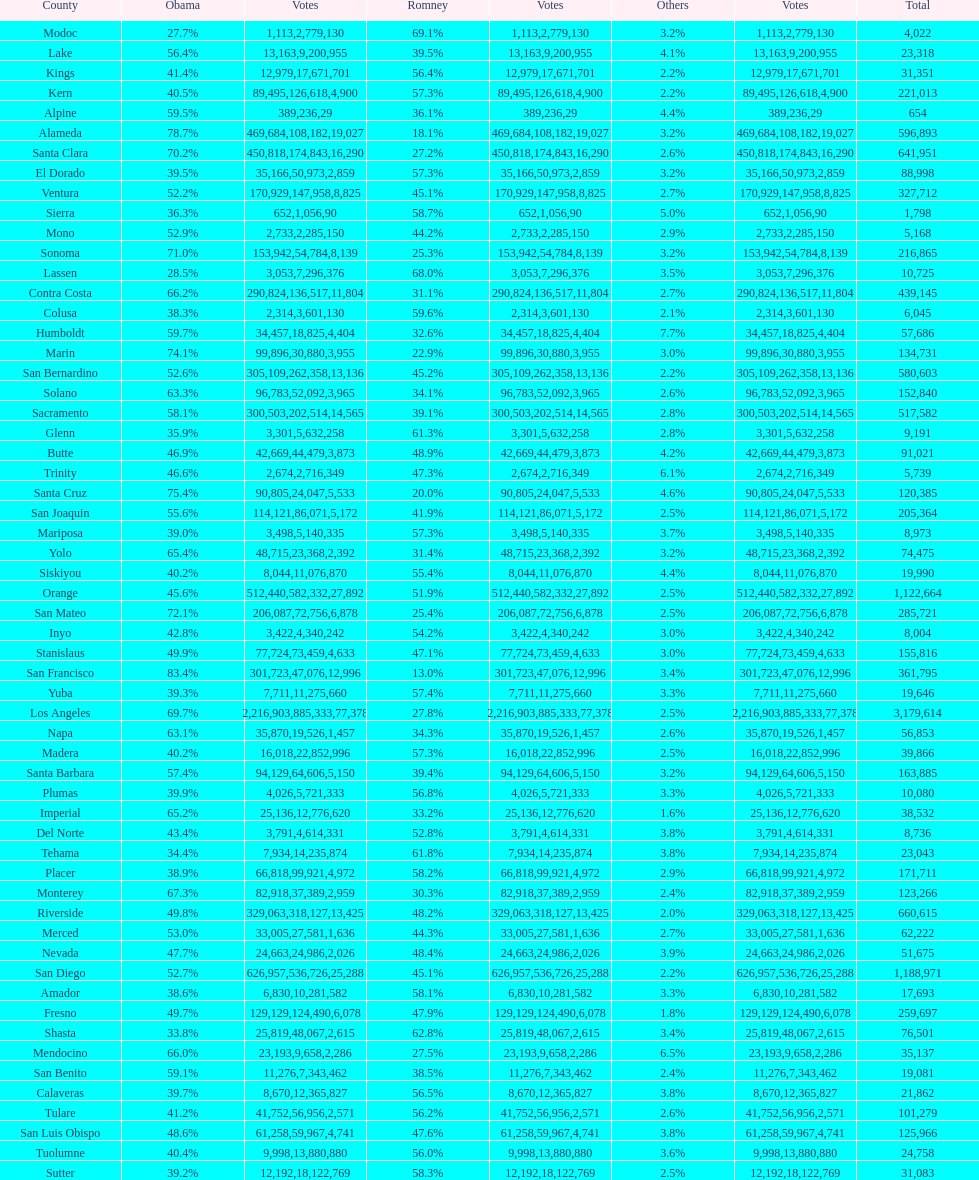Which count had the least number of votes for obama? Modoc. 